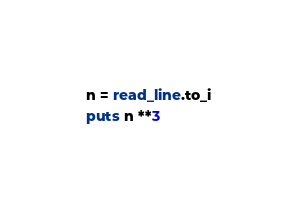Convert code to text. <code><loc_0><loc_0><loc_500><loc_500><_Crystal_>n = read_line.to_i
puts n **3
</code> 